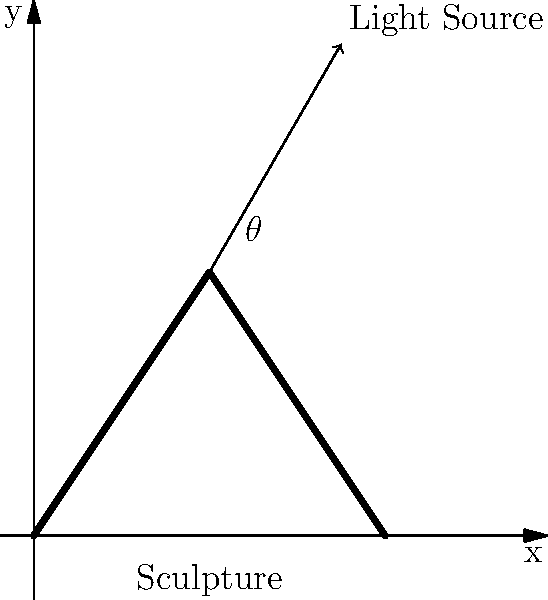As an artist preparing for your first sculpture exhibition, you're experimenting with lighting to enhance the texture of your pieces. You've noticed that the ideal lighting angle $\theta$ to highlight the texture of a sculpture is related to its surface normal vector. If the average surface normal of your sculpture makes an angle of 30° with the vertical, what should be the angle $\theta$ of your light source from the vertical to maximize the visibility of the texture? To solve this problem, we need to understand the principle of maximum contrast in lighting:

1. The angle of incidence of light that produces maximum contrast (and thus highlights texture) is when the light is perpendicular to the surface normal vector.

2. Given:
   - The surface normal makes an angle of 30° with the vertical.
   - We need to find the angle $\theta$ of the light source from the vertical.

3. For the light to be perpendicular to the surface normal:
   - The angle between the light and the surface normal should be 90°.

4. We can set up an equation:
   $\theta + 30° = 90°$

5. Solving for $\theta$:
   $\theta = 90° - 30° = 60°$

Therefore, the light source should be positioned at an angle of 60° from the vertical to maximize the visibility of the sculpture's texture.
Answer: 60° 